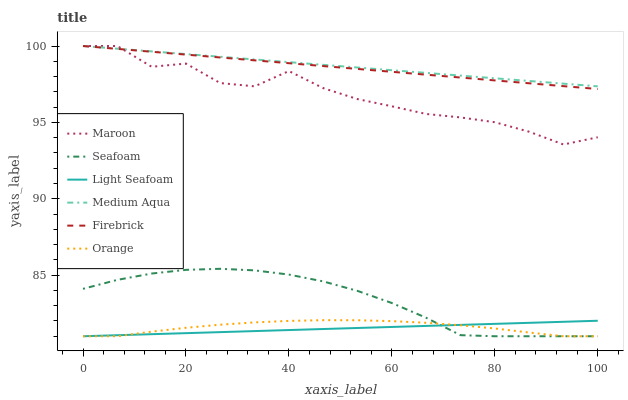Does Light Seafoam have the minimum area under the curve?
Answer yes or no. Yes. Does Medium Aqua have the maximum area under the curve?
Answer yes or no. Yes. Does Seafoam have the minimum area under the curve?
Answer yes or no. No. Does Seafoam have the maximum area under the curve?
Answer yes or no. No. Is Light Seafoam the smoothest?
Answer yes or no. Yes. Is Maroon the roughest?
Answer yes or no. Yes. Is Seafoam the smoothest?
Answer yes or no. No. Is Seafoam the roughest?
Answer yes or no. No. Does Seafoam have the lowest value?
Answer yes or no. Yes. Does Maroon have the lowest value?
Answer yes or no. No. Does Medium Aqua have the highest value?
Answer yes or no. Yes. Does Seafoam have the highest value?
Answer yes or no. No. Is Orange less than Firebrick?
Answer yes or no. Yes. Is Medium Aqua greater than Light Seafoam?
Answer yes or no. Yes. Does Firebrick intersect Maroon?
Answer yes or no. Yes. Is Firebrick less than Maroon?
Answer yes or no. No. Is Firebrick greater than Maroon?
Answer yes or no. No. Does Orange intersect Firebrick?
Answer yes or no. No. 